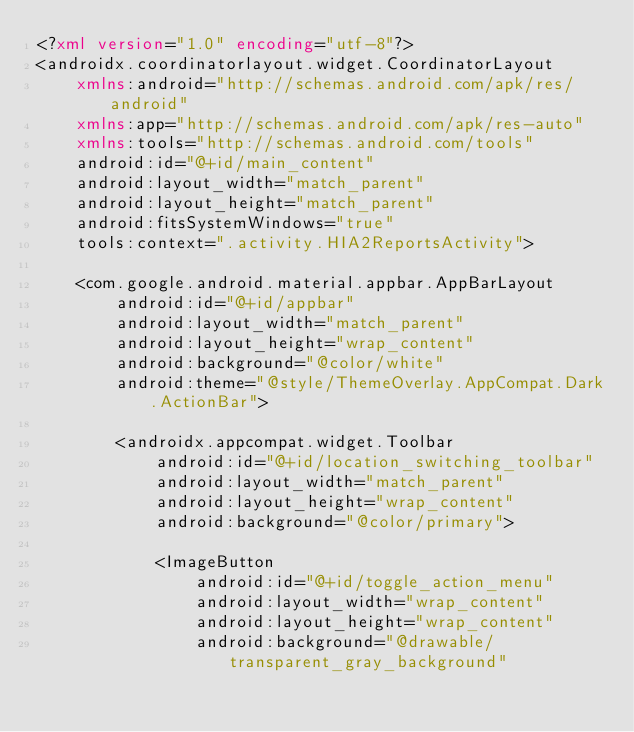<code> <loc_0><loc_0><loc_500><loc_500><_XML_><?xml version="1.0" encoding="utf-8"?>
<androidx.coordinatorlayout.widget.CoordinatorLayout
    xmlns:android="http://schemas.android.com/apk/res/android"
    xmlns:app="http://schemas.android.com/apk/res-auto"
    xmlns:tools="http://schemas.android.com/tools"
    android:id="@+id/main_content"
    android:layout_width="match_parent"
    android:layout_height="match_parent"
    android:fitsSystemWindows="true"
    tools:context=".activity.HIA2ReportsActivity">

    <com.google.android.material.appbar.AppBarLayout
        android:id="@+id/appbar"
        android:layout_width="match_parent"
        android:layout_height="wrap_content"
        android:background="@color/white"
        android:theme="@style/ThemeOverlay.AppCompat.Dark.ActionBar">

        <androidx.appcompat.widget.Toolbar
            android:id="@+id/location_switching_toolbar"
            android:layout_width="match_parent"
            android:layout_height="wrap_content"
            android:background="@color/primary">

            <ImageButton
                android:id="@+id/toggle_action_menu"
                android:layout_width="wrap_content"
                android:layout_height="wrap_content"
                android:background="@drawable/transparent_gray_background"</code> 